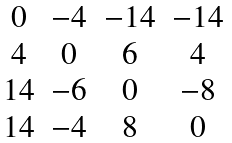Convert formula to latex. <formula><loc_0><loc_0><loc_500><loc_500>\begin{matrix} 0 & - 4 & - 1 4 & - 1 4 \\ 4 & 0 & 6 & 4 \\ 1 4 & - 6 & 0 & - 8 \\ 1 4 & - 4 & 8 & 0 \end{matrix}</formula> 